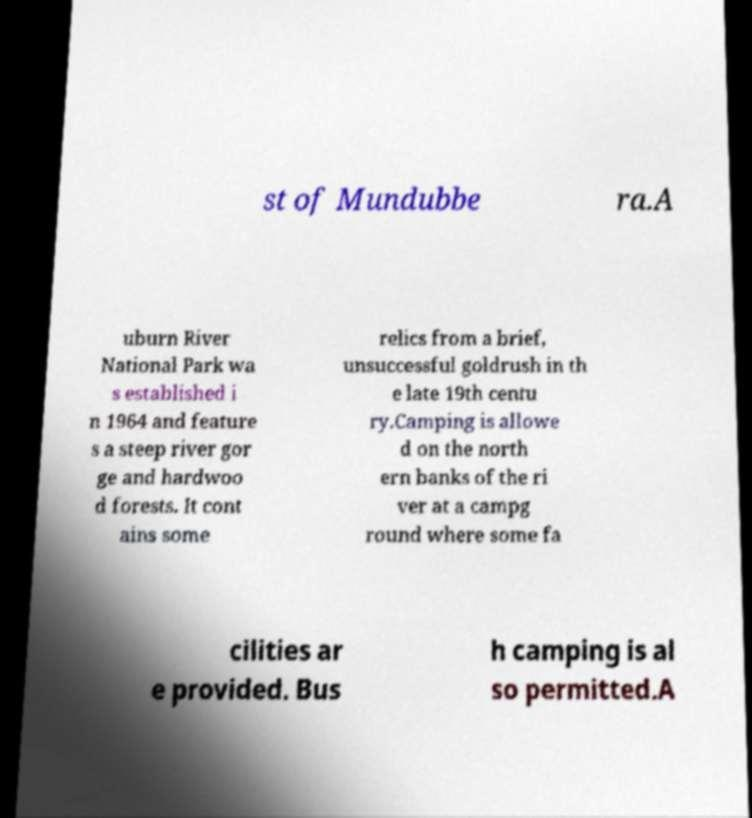What messages or text are displayed in this image? I need them in a readable, typed format. st of Mundubbe ra.A uburn River National Park wa s established i n 1964 and feature s a steep river gor ge and hardwoo d forests. It cont ains some relics from a brief, unsuccessful goldrush in th e late 19th centu ry.Camping is allowe d on the north ern banks of the ri ver at a campg round where some fa cilities ar e provided. Bus h camping is al so permitted.A 